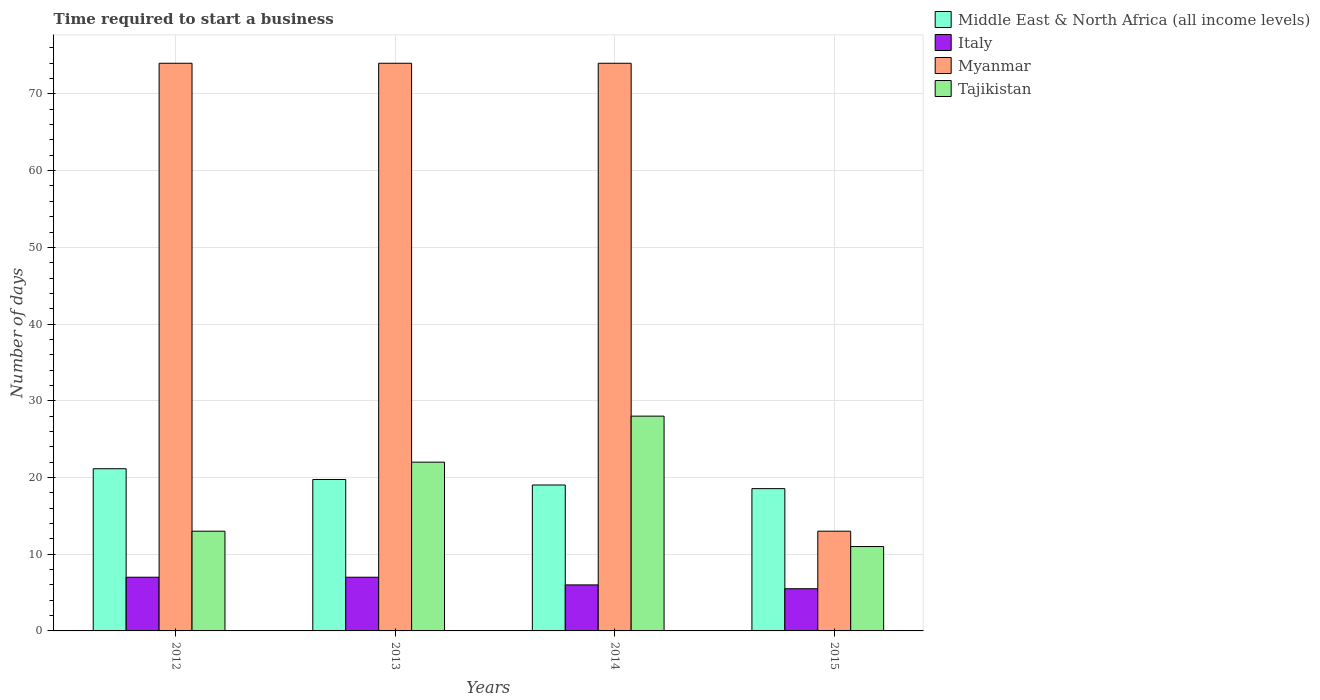How many different coloured bars are there?
Your answer should be compact. 4. Are the number of bars per tick equal to the number of legend labels?
Your answer should be very brief. Yes. Are the number of bars on each tick of the X-axis equal?
Give a very brief answer. Yes. What is the label of the 2nd group of bars from the left?
Your answer should be very brief. 2013. In how many cases, is the number of bars for a given year not equal to the number of legend labels?
Offer a terse response. 0. Across all years, what is the maximum number of days required to start a business in Myanmar?
Your answer should be compact. 74. Across all years, what is the minimum number of days required to start a business in Middle East & North Africa (all income levels)?
Offer a terse response. 18.55. In which year was the number of days required to start a business in Myanmar minimum?
Keep it short and to the point. 2015. What is the total number of days required to start a business in Tajikistan in the graph?
Offer a very short reply. 74. What is the difference between the number of days required to start a business in Tajikistan in 2012 and that in 2014?
Keep it short and to the point. -15. What is the difference between the number of days required to start a business in Italy in 2014 and the number of days required to start a business in Middle East & North Africa (all income levels) in 2013?
Your answer should be compact. -13.74. What is the average number of days required to start a business in Middle East & North Africa (all income levels) per year?
Give a very brief answer. 19.61. In the year 2015, what is the difference between the number of days required to start a business in Myanmar and number of days required to start a business in Middle East & North Africa (all income levels)?
Provide a succinct answer. -5.55. What is the ratio of the number of days required to start a business in Tajikistan in 2012 to that in 2014?
Your response must be concise. 0.46. What is the difference between the highest and the second highest number of days required to start a business in Myanmar?
Your response must be concise. 0. What is the difference between the highest and the lowest number of days required to start a business in Italy?
Your answer should be compact. 1.5. Is the sum of the number of days required to start a business in Myanmar in 2012 and 2015 greater than the maximum number of days required to start a business in Italy across all years?
Offer a very short reply. Yes. Is it the case that in every year, the sum of the number of days required to start a business in Middle East & North Africa (all income levels) and number of days required to start a business in Italy is greater than the sum of number of days required to start a business in Tajikistan and number of days required to start a business in Myanmar?
Provide a short and direct response. No. What does the 3rd bar from the left in 2012 represents?
Keep it short and to the point. Myanmar. What does the 1st bar from the right in 2015 represents?
Keep it short and to the point. Tajikistan. Is it the case that in every year, the sum of the number of days required to start a business in Tajikistan and number of days required to start a business in Italy is greater than the number of days required to start a business in Middle East & North Africa (all income levels)?
Ensure brevity in your answer.  No. How many bars are there?
Your answer should be compact. 16. What is the difference between two consecutive major ticks on the Y-axis?
Provide a short and direct response. 10. Does the graph contain any zero values?
Your answer should be very brief. No. Does the graph contain grids?
Ensure brevity in your answer.  Yes. How are the legend labels stacked?
Your answer should be compact. Vertical. What is the title of the graph?
Your answer should be very brief. Time required to start a business. What is the label or title of the X-axis?
Ensure brevity in your answer.  Years. What is the label or title of the Y-axis?
Provide a succinct answer. Number of days. What is the Number of days in Middle East & North Africa (all income levels) in 2012?
Give a very brief answer. 21.14. What is the Number of days in Tajikistan in 2012?
Provide a short and direct response. 13. What is the Number of days of Middle East & North Africa (all income levels) in 2013?
Provide a short and direct response. 19.74. What is the Number of days of Myanmar in 2013?
Your response must be concise. 74. What is the Number of days in Tajikistan in 2013?
Offer a terse response. 22. What is the Number of days in Middle East & North Africa (all income levels) in 2014?
Your response must be concise. 19.02. What is the Number of days in Italy in 2014?
Give a very brief answer. 6. What is the Number of days in Middle East & North Africa (all income levels) in 2015?
Your answer should be compact. 18.55. What is the Number of days of Tajikistan in 2015?
Your answer should be very brief. 11. Across all years, what is the maximum Number of days in Middle East & North Africa (all income levels)?
Give a very brief answer. 21.14. Across all years, what is the minimum Number of days of Middle East & North Africa (all income levels)?
Give a very brief answer. 18.55. What is the total Number of days of Middle East & North Africa (all income levels) in the graph?
Keep it short and to the point. 78.45. What is the total Number of days of Myanmar in the graph?
Your answer should be very brief. 235. What is the total Number of days in Tajikistan in the graph?
Give a very brief answer. 74. What is the difference between the Number of days of Middle East & North Africa (all income levels) in 2012 and that in 2013?
Provide a succinct answer. 1.4. What is the difference between the Number of days of Myanmar in 2012 and that in 2013?
Offer a terse response. 0. What is the difference between the Number of days of Middle East & North Africa (all income levels) in 2012 and that in 2014?
Provide a short and direct response. 2.12. What is the difference between the Number of days in Italy in 2012 and that in 2014?
Ensure brevity in your answer.  1. What is the difference between the Number of days of Myanmar in 2012 and that in 2014?
Your answer should be very brief. 0. What is the difference between the Number of days of Tajikistan in 2012 and that in 2014?
Make the answer very short. -15. What is the difference between the Number of days of Middle East & North Africa (all income levels) in 2012 and that in 2015?
Give a very brief answer. 2.6. What is the difference between the Number of days of Italy in 2012 and that in 2015?
Provide a succinct answer. 1.5. What is the difference between the Number of days in Myanmar in 2012 and that in 2015?
Provide a succinct answer. 61. What is the difference between the Number of days of Italy in 2013 and that in 2014?
Your response must be concise. 1. What is the difference between the Number of days of Myanmar in 2013 and that in 2014?
Provide a succinct answer. 0. What is the difference between the Number of days of Tajikistan in 2013 and that in 2014?
Your response must be concise. -6. What is the difference between the Number of days of Middle East & North Africa (all income levels) in 2013 and that in 2015?
Ensure brevity in your answer.  1.19. What is the difference between the Number of days of Tajikistan in 2013 and that in 2015?
Your answer should be compact. 11. What is the difference between the Number of days of Middle East & North Africa (all income levels) in 2014 and that in 2015?
Provide a succinct answer. 0.48. What is the difference between the Number of days in Italy in 2014 and that in 2015?
Make the answer very short. 0.5. What is the difference between the Number of days in Middle East & North Africa (all income levels) in 2012 and the Number of days in Italy in 2013?
Offer a terse response. 14.14. What is the difference between the Number of days of Middle East & North Africa (all income levels) in 2012 and the Number of days of Myanmar in 2013?
Your response must be concise. -52.86. What is the difference between the Number of days of Middle East & North Africa (all income levels) in 2012 and the Number of days of Tajikistan in 2013?
Keep it short and to the point. -0.86. What is the difference between the Number of days of Italy in 2012 and the Number of days of Myanmar in 2013?
Provide a short and direct response. -67. What is the difference between the Number of days in Myanmar in 2012 and the Number of days in Tajikistan in 2013?
Give a very brief answer. 52. What is the difference between the Number of days of Middle East & North Africa (all income levels) in 2012 and the Number of days of Italy in 2014?
Provide a short and direct response. 15.14. What is the difference between the Number of days in Middle East & North Africa (all income levels) in 2012 and the Number of days in Myanmar in 2014?
Ensure brevity in your answer.  -52.86. What is the difference between the Number of days in Middle East & North Africa (all income levels) in 2012 and the Number of days in Tajikistan in 2014?
Offer a very short reply. -6.86. What is the difference between the Number of days of Italy in 2012 and the Number of days of Myanmar in 2014?
Your answer should be very brief. -67. What is the difference between the Number of days of Italy in 2012 and the Number of days of Tajikistan in 2014?
Offer a very short reply. -21. What is the difference between the Number of days of Myanmar in 2012 and the Number of days of Tajikistan in 2014?
Give a very brief answer. 46. What is the difference between the Number of days in Middle East & North Africa (all income levels) in 2012 and the Number of days in Italy in 2015?
Ensure brevity in your answer.  15.64. What is the difference between the Number of days of Middle East & North Africa (all income levels) in 2012 and the Number of days of Myanmar in 2015?
Provide a short and direct response. 8.14. What is the difference between the Number of days of Middle East & North Africa (all income levels) in 2012 and the Number of days of Tajikistan in 2015?
Your answer should be very brief. 10.14. What is the difference between the Number of days in Myanmar in 2012 and the Number of days in Tajikistan in 2015?
Give a very brief answer. 63. What is the difference between the Number of days of Middle East & North Africa (all income levels) in 2013 and the Number of days of Italy in 2014?
Give a very brief answer. 13.74. What is the difference between the Number of days of Middle East & North Africa (all income levels) in 2013 and the Number of days of Myanmar in 2014?
Your response must be concise. -54.26. What is the difference between the Number of days of Middle East & North Africa (all income levels) in 2013 and the Number of days of Tajikistan in 2014?
Provide a succinct answer. -8.26. What is the difference between the Number of days of Italy in 2013 and the Number of days of Myanmar in 2014?
Keep it short and to the point. -67. What is the difference between the Number of days in Middle East & North Africa (all income levels) in 2013 and the Number of days in Italy in 2015?
Keep it short and to the point. 14.24. What is the difference between the Number of days in Middle East & North Africa (all income levels) in 2013 and the Number of days in Myanmar in 2015?
Provide a succinct answer. 6.74. What is the difference between the Number of days of Middle East & North Africa (all income levels) in 2013 and the Number of days of Tajikistan in 2015?
Ensure brevity in your answer.  8.74. What is the difference between the Number of days of Italy in 2013 and the Number of days of Myanmar in 2015?
Make the answer very short. -6. What is the difference between the Number of days in Myanmar in 2013 and the Number of days in Tajikistan in 2015?
Your answer should be compact. 63. What is the difference between the Number of days in Middle East & North Africa (all income levels) in 2014 and the Number of days in Italy in 2015?
Ensure brevity in your answer.  13.52. What is the difference between the Number of days of Middle East & North Africa (all income levels) in 2014 and the Number of days of Myanmar in 2015?
Offer a very short reply. 6.02. What is the difference between the Number of days in Middle East & North Africa (all income levels) in 2014 and the Number of days in Tajikistan in 2015?
Provide a short and direct response. 8.02. What is the difference between the Number of days in Italy in 2014 and the Number of days in Tajikistan in 2015?
Your response must be concise. -5. What is the difference between the Number of days of Myanmar in 2014 and the Number of days of Tajikistan in 2015?
Ensure brevity in your answer.  63. What is the average Number of days in Middle East & North Africa (all income levels) per year?
Ensure brevity in your answer.  19.61. What is the average Number of days in Italy per year?
Your answer should be compact. 6.38. What is the average Number of days of Myanmar per year?
Offer a terse response. 58.75. What is the average Number of days in Tajikistan per year?
Your answer should be very brief. 18.5. In the year 2012, what is the difference between the Number of days in Middle East & North Africa (all income levels) and Number of days in Italy?
Offer a terse response. 14.14. In the year 2012, what is the difference between the Number of days of Middle East & North Africa (all income levels) and Number of days of Myanmar?
Offer a terse response. -52.86. In the year 2012, what is the difference between the Number of days in Middle East & North Africa (all income levels) and Number of days in Tajikistan?
Your answer should be very brief. 8.14. In the year 2012, what is the difference between the Number of days of Italy and Number of days of Myanmar?
Offer a terse response. -67. In the year 2012, what is the difference between the Number of days in Myanmar and Number of days in Tajikistan?
Ensure brevity in your answer.  61. In the year 2013, what is the difference between the Number of days of Middle East & North Africa (all income levels) and Number of days of Italy?
Provide a succinct answer. 12.74. In the year 2013, what is the difference between the Number of days in Middle East & North Africa (all income levels) and Number of days in Myanmar?
Offer a terse response. -54.26. In the year 2013, what is the difference between the Number of days in Middle East & North Africa (all income levels) and Number of days in Tajikistan?
Provide a short and direct response. -2.26. In the year 2013, what is the difference between the Number of days in Italy and Number of days in Myanmar?
Your response must be concise. -67. In the year 2013, what is the difference between the Number of days in Italy and Number of days in Tajikistan?
Keep it short and to the point. -15. In the year 2014, what is the difference between the Number of days in Middle East & North Africa (all income levels) and Number of days in Italy?
Keep it short and to the point. 13.02. In the year 2014, what is the difference between the Number of days in Middle East & North Africa (all income levels) and Number of days in Myanmar?
Keep it short and to the point. -54.98. In the year 2014, what is the difference between the Number of days in Middle East & North Africa (all income levels) and Number of days in Tajikistan?
Your answer should be compact. -8.98. In the year 2014, what is the difference between the Number of days in Italy and Number of days in Myanmar?
Offer a terse response. -68. In the year 2014, what is the difference between the Number of days in Italy and Number of days in Tajikistan?
Your answer should be very brief. -22. In the year 2015, what is the difference between the Number of days of Middle East & North Africa (all income levels) and Number of days of Italy?
Your answer should be very brief. 13.05. In the year 2015, what is the difference between the Number of days of Middle East & North Africa (all income levels) and Number of days of Myanmar?
Provide a succinct answer. 5.55. In the year 2015, what is the difference between the Number of days in Middle East & North Africa (all income levels) and Number of days in Tajikistan?
Provide a short and direct response. 7.55. In the year 2015, what is the difference between the Number of days in Italy and Number of days in Tajikistan?
Your answer should be compact. -5.5. In the year 2015, what is the difference between the Number of days of Myanmar and Number of days of Tajikistan?
Make the answer very short. 2. What is the ratio of the Number of days in Middle East & North Africa (all income levels) in 2012 to that in 2013?
Give a very brief answer. 1.07. What is the ratio of the Number of days in Tajikistan in 2012 to that in 2013?
Give a very brief answer. 0.59. What is the ratio of the Number of days of Middle East & North Africa (all income levels) in 2012 to that in 2014?
Make the answer very short. 1.11. What is the ratio of the Number of days of Italy in 2012 to that in 2014?
Your answer should be compact. 1.17. What is the ratio of the Number of days of Tajikistan in 2012 to that in 2014?
Provide a short and direct response. 0.46. What is the ratio of the Number of days in Middle East & North Africa (all income levels) in 2012 to that in 2015?
Your answer should be very brief. 1.14. What is the ratio of the Number of days in Italy in 2012 to that in 2015?
Your answer should be very brief. 1.27. What is the ratio of the Number of days of Myanmar in 2012 to that in 2015?
Offer a very short reply. 5.69. What is the ratio of the Number of days in Tajikistan in 2012 to that in 2015?
Provide a short and direct response. 1.18. What is the ratio of the Number of days of Middle East & North Africa (all income levels) in 2013 to that in 2014?
Keep it short and to the point. 1.04. What is the ratio of the Number of days of Italy in 2013 to that in 2014?
Offer a terse response. 1.17. What is the ratio of the Number of days in Myanmar in 2013 to that in 2014?
Provide a short and direct response. 1. What is the ratio of the Number of days in Tajikistan in 2013 to that in 2014?
Offer a terse response. 0.79. What is the ratio of the Number of days of Middle East & North Africa (all income levels) in 2013 to that in 2015?
Give a very brief answer. 1.06. What is the ratio of the Number of days of Italy in 2013 to that in 2015?
Offer a very short reply. 1.27. What is the ratio of the Number of days in Myanmar in 2013 to that in 2015?
Ensure brevity in your answer.  5.69. What is the ratio of the Number of days in Tajikistan in 2013 to that in 2015?
Provide a succinct answer. 2. What is the ratio of the Number of days of Middle East & North Africa (all income levels) in 2014 to that in 2015?
Provide a succinct answer. 1.03. What is the ratio of the Number of days of Myanmar in 2014 to that in 2015?
Make the answer very short. 5.69. What is the ratio of the Number of days in Tajikistan in 2014 to that in 2015?
Ensure brevity in your answer.  2.55. What is the difference between the highest and the second highest Number of days in Middle East & North Africa (all income levels)?
Provide a succinct answer. 1.4. What is the difference between the highest and the second highest Number of days in Myanmar?
Offer a terse response. 0. What is the difference between the highest and the lowest Number of days in Middle East & North Africa (all income levels)?
Offer a terse response. 2.6. What is the difference between the highest and the lowest Number of days of Italy?
Make the answer very short. 1.5. What is the difference between the highest and the lowest Number of days of Myanmar?
Provide a short and direct response. 61. 